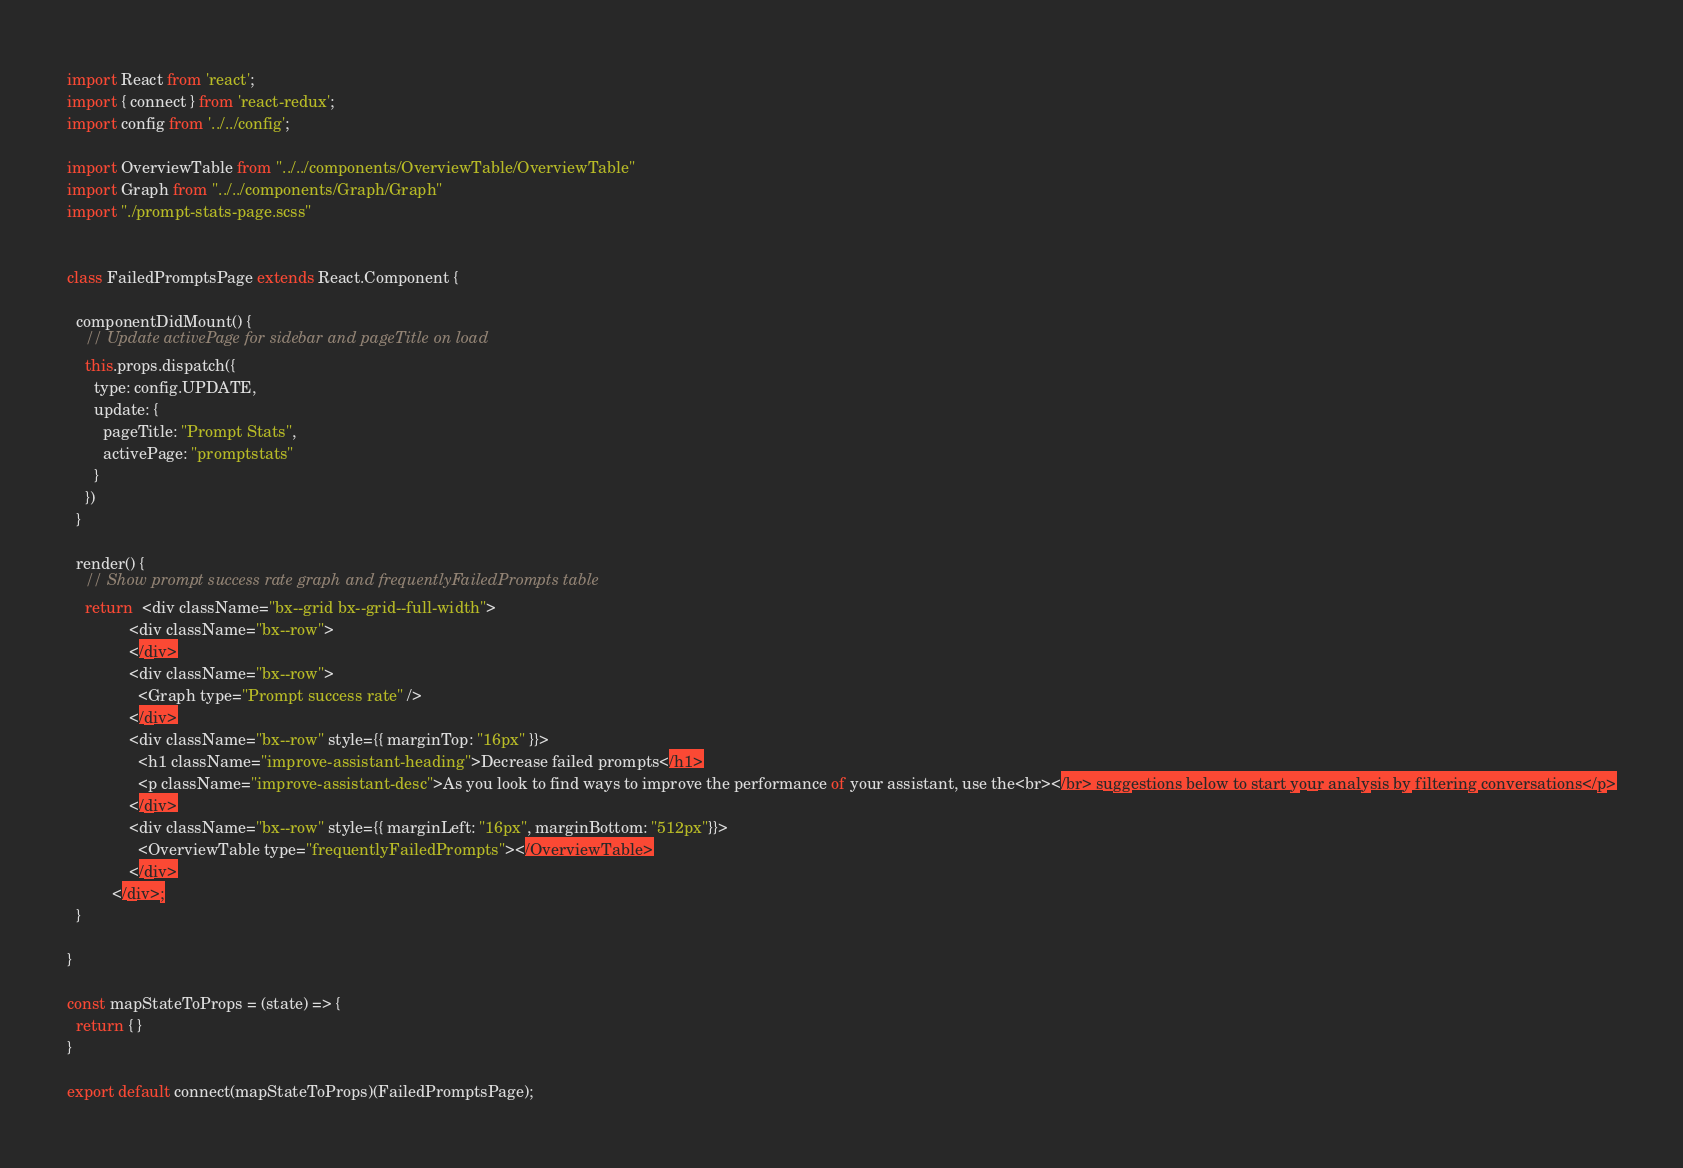<code> <loc_0><loc_0><loc_500><loc_500><_JavaScript_>import React from 'react';
import { connect } from 'react-redux';
import config from '../../config';

import OverviewTable from "../../components/OverviewTable/OverviewTable"
import Graph from "../../components/Graph/Graph"
import "./prompt-stats-page.scss"


class FailedPromptsPage extends React.Component {

  componentDidMount() {
    // Update activePage for sidebar and pageTitle on load
    this.props.dispatch({
      type: config.UPDATE,
      update: {
        pageTitle: "Prompt Stats",
        activePage: "promptstats"
      }
    })
  }

  render() {
    // Show prompt success rate graph and frequentlyFailedPrompts table
    return  <div className="bx--grid bx--grid--full-width">
              <div className="bx--row">
              </div>
              <div className="bx--row">
                <Graph type="Prompt success rate" /> 
              </div>
              <div className="bx--row" style={{ marginTop: "16px" }}>
                <h1 className="improve-assistant-heading">Decrease failed prompts</h1>
                <p className="improve-assistant-desc">As you look to find ways to improve the performance of your assistant, use the<br></br> suggestions below to start your analysis by filtering conversations</p>
              </div>
              <div className="bx--row" style={{ marginLeft: "16px", marginBottom: "512px"}}>
                <OverviewTable type="frequentlyFailedPrompts"></OverviewTable>
              </div>
          </div>;
  }

}

const mapStateToProps = (state) => {
  return { }
}

export default connect(mapStateToProps)(FailedPromptsPage);</code> 